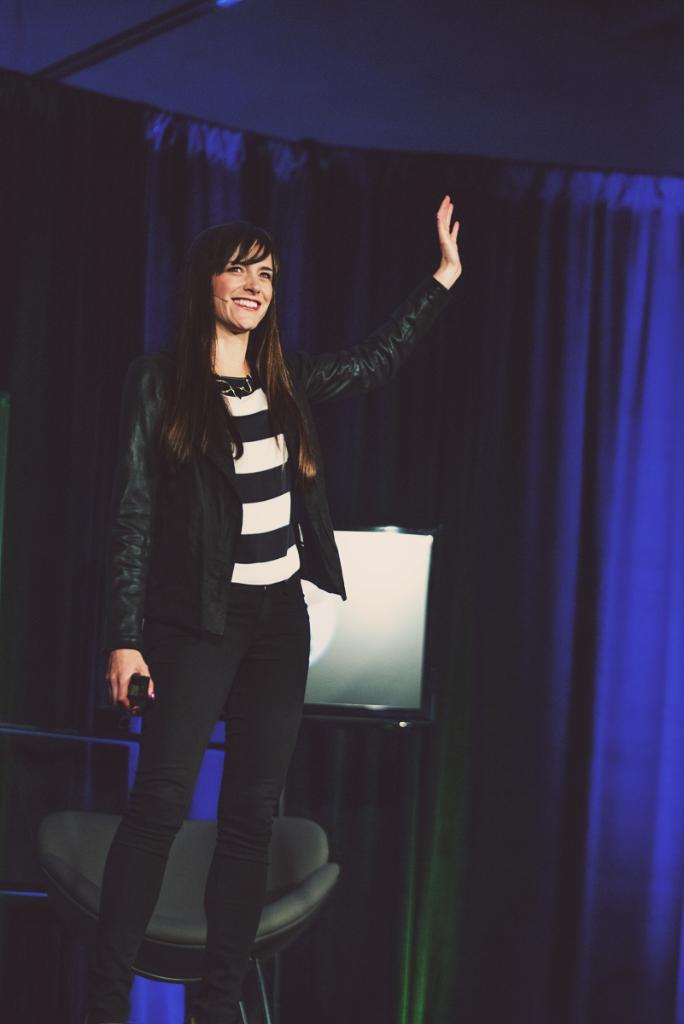What color is the curtain in the background of the image? There is a blue color curtain in the backdrop. Who is present in the image? There is a woman standing in the image. What is the woman wearing? The woman is wearing a jacket. What is the woman doing with her hand? The woman is waving her hand. What is the woman's facial expression? A: The woman is smiling. How many snakes are crawling on the woman's jacket in the image? There are no snakes present in the image; the woman is wearing a jacket without any snakes. What type of property is visible in the image? There is no property visible in the image; it features a woman standing in front of a blue curtain. 